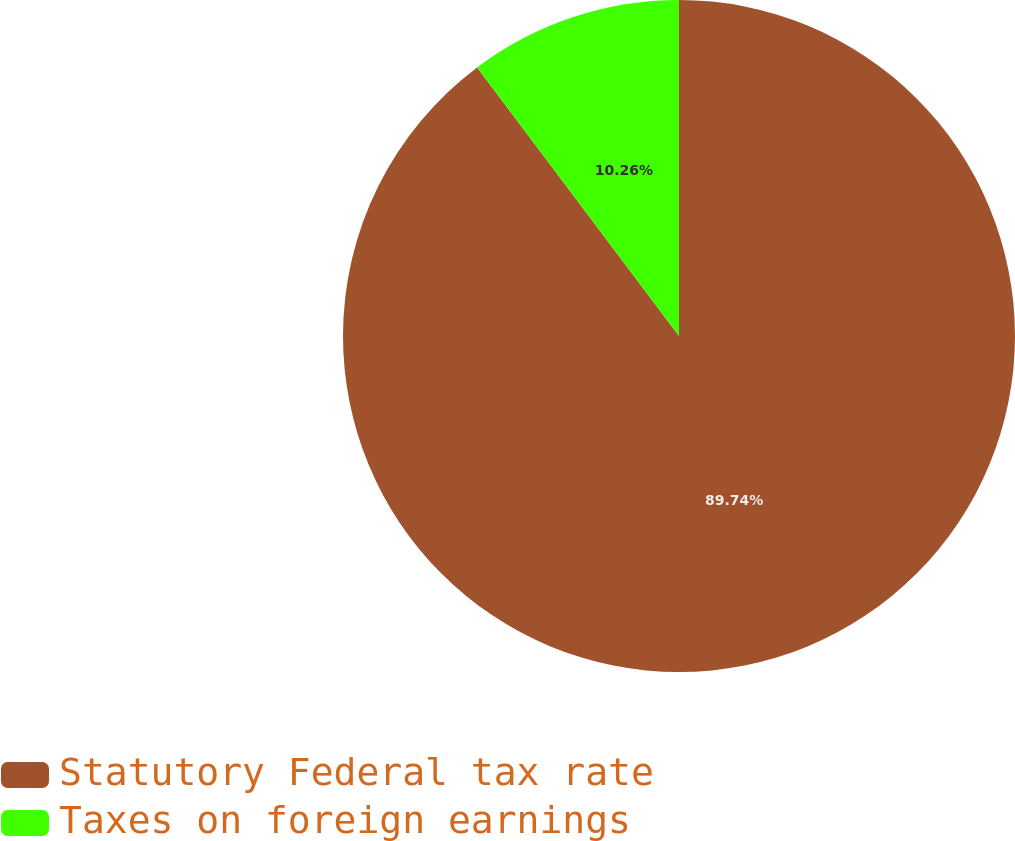<chart> <loc_0><loc_0><loc_500><loc_500><pie_chart><fcel>Statutory Federal tax rate<fcel>Taxes on foreign earnings<nl><fcel>89.74%<fcel>10.26%<nl></chart> 